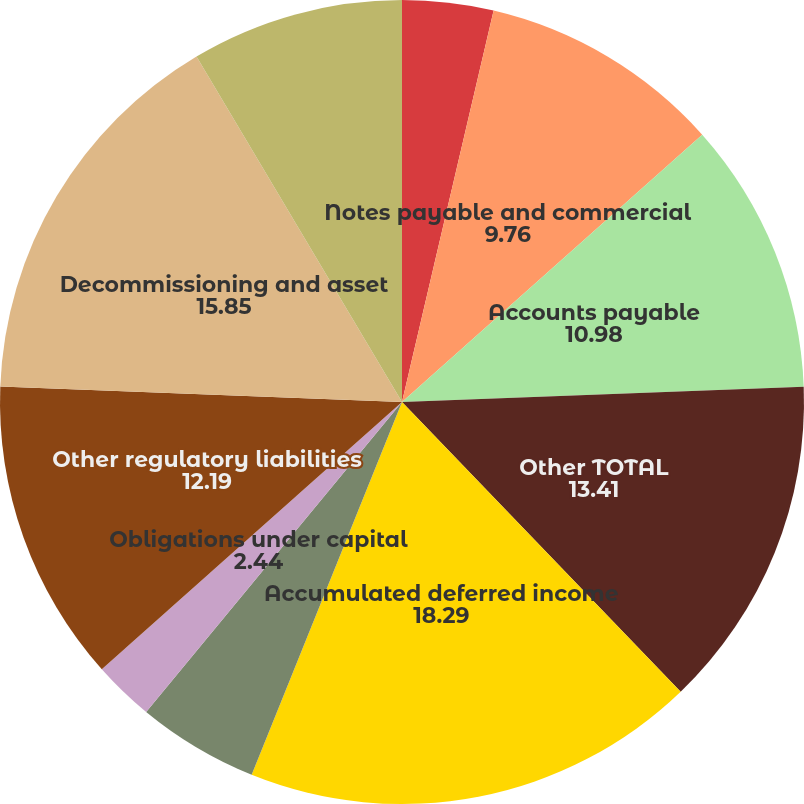Convert chart. <chart><loc_0><loc_0><loc_500><loc_500><pie_chart><fcel>Currently maturing long-term<fcel>Notes payable and commercial<fcel>Accounts payable<fcel>Other TOTAL<fcel>Accumulated deferred income<fcel>Accumulated deferred<fcel>Obligations under capital<fcel>Other regulatory liabilities<fcel>Decommissioning and asset<fcel>Accumulated provisions<nl><fcel>3.66%<fcel>9.76%<fcel>10.98%<fcel>13.41%<fcel>18.29%<fcel>4.88%<fcel>2.44%<fcel>12.19%<fcel>15.85%<fcel>8.54%<nl></chart> 